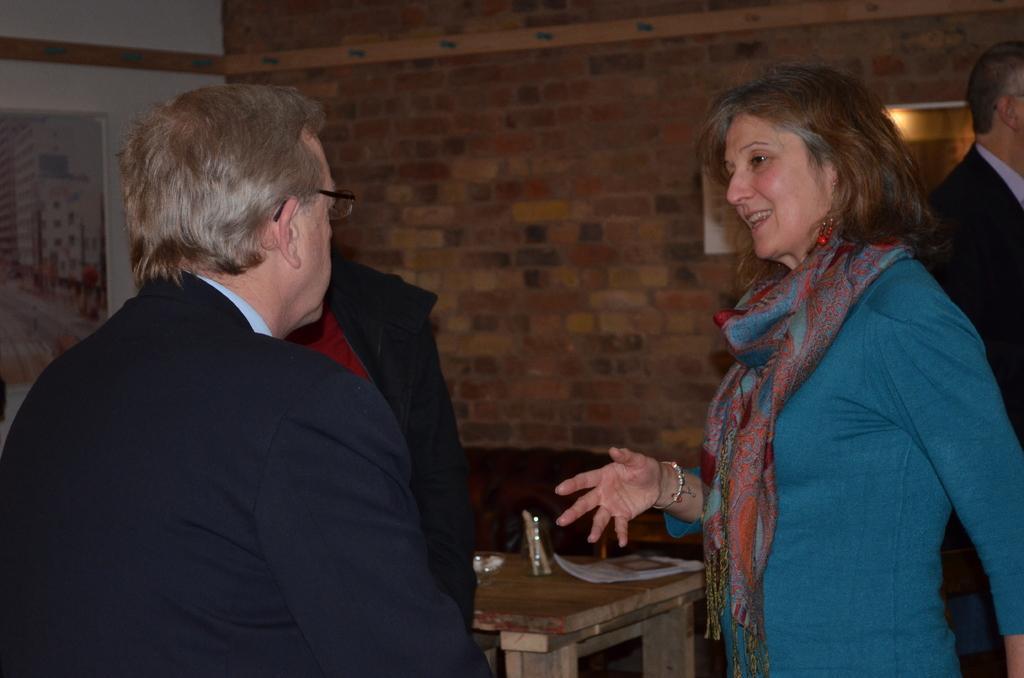Describe this image in one or two sentences. This is the picture inside of the room. There is a woman with blue shirt is standing and talking and there is a man with black suit is listening. At the back there's a wall. There are glasses, papers on the table. At the left there is a frame on the wall. 